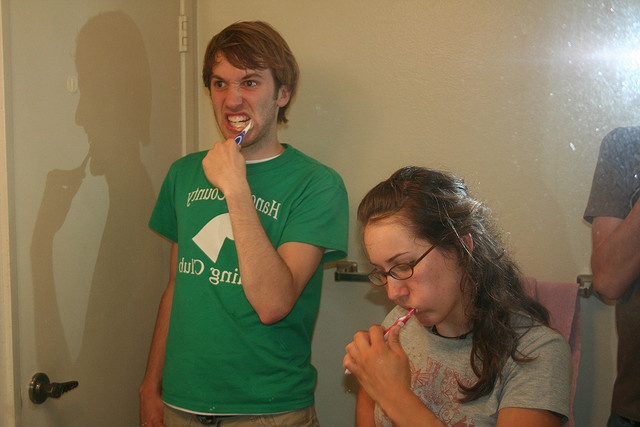Describe the objects in this image and their specific colors. I can see people in tan, darkgreen, gray, and maroon tones, people in tan, black, gray, and brown tones, people in tan, gray, black, brown, and maroon tones, toothbrush in tan, brown, and salmon tones, and toothbrush in tan, gray, darkgray, and navy tones in this image. 